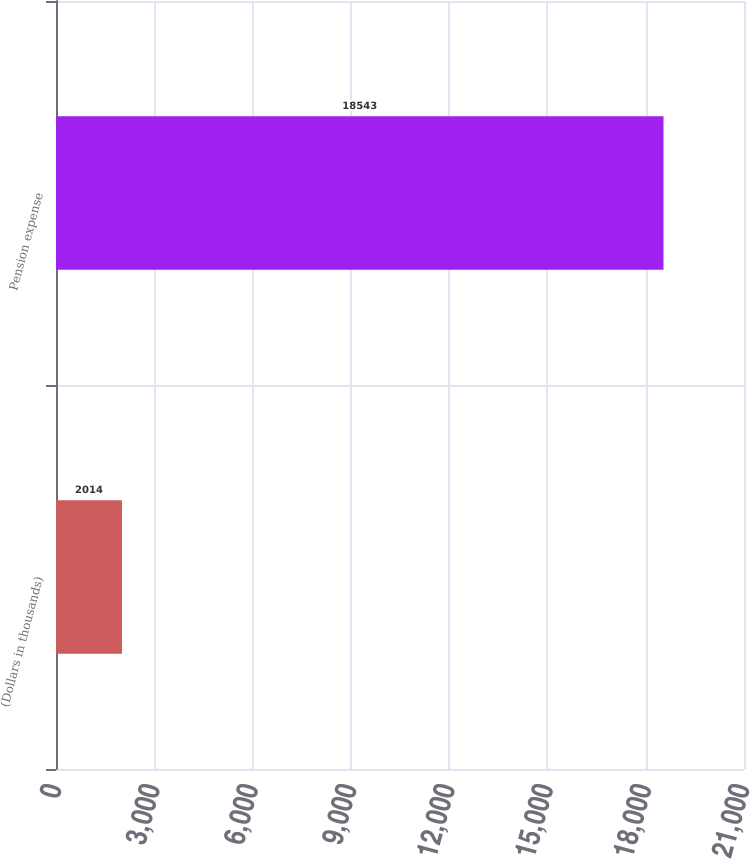Convert chart. <chart><loc_0><loc_0><loc_500><loc_500><bar_chart><fcel>(Dollars in thousands)<fcel>Pension expense<nl><fcel>2014<fcel>18543<nl></chart> 